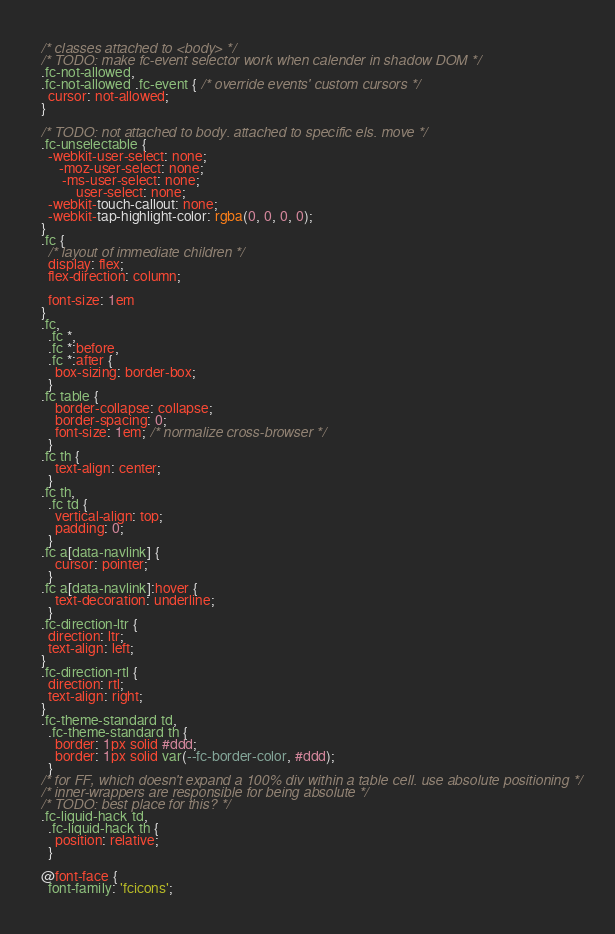Convert code to text. <code><loc_0><loc_0><loc_500><loc_500><_CSS_>
/* classes attached to <body> */
/* TODO: make fc-event selector work when calender in shadow DOM */
.fc-not-allowed,
.fc-not-allowed .fc-event { /* override events' custom cursors */
  cursor: not-allowed;
}

/* TODO: not attached to body. attached to specific els. move */
.fc-unselectable {
  -webkit-user-select: none;
     -moz-user-select: none;
      -ms-user-select: none;
          user-select: none;
  -webkit-touch-callout: none;
  -webkit-tap-highlight-color: rgba(0, 0, 0, 0);
}
.fc {
  /* layout of immediate children */
  display: flex;
  flex-direction: column;

  font-size: 1em
}
.fc,
  .fc *,
  .fc *:before,
  .fc *:after {
    box-sizing: border-box;
  }
.fc table {
    border-collapse: collapse;
    border-spacing: 0;
    font-size: 1em; /* normalize cross-browser */
  }
.fc th {
    text-align: center;
  }
.fc th,
  .fc td {
    vertical-align: top;
    padding: 0;
  }
.fc a[data-navlink] {
    cursor: pointer;
  }
.fc a[data-navlink]:hover {
    text-decoration: underline;
  }
.fc-direction-ltr {
  direction: ltr;
  text-align: left;
}
.fc-direction-rtl {
  direction: rtl;
  text-align: right;
}
.fc-theme-standard td,
  .fc-theme-standard th {
    border: 1px solid #ddd;
    border: 1px solid var(--fc-border-color, #ddd);
  }
/* for FF, which doesn't expand a 100% div within a table cell. use absolute positioning */
/* inner-wrappers are responsible for being absolute */
/* TODO: best place for this? */
.fc-liquid-hack td,
  .fc-liquid-hack th {
    position: relative;
  }

@font-face {
  font-family: 'fcicons';</code> 